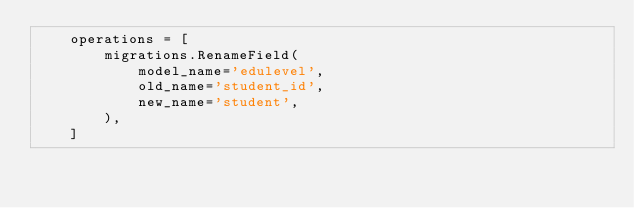Convert code to text. <code><loc_0><loc_0><loc_500><loc_500><_Python_>    operations = [
        migrations.RenameField(
            model_name='edulevel',
            old_name='student_id',
            new_name='student',
        ),
    ]
</code> 